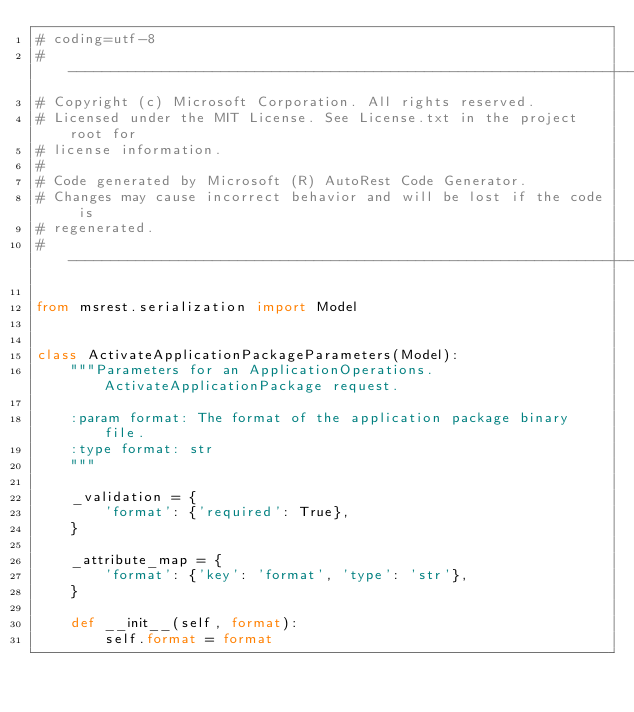<code> <loc_0><loc_0><loc_500><loc_500><_Python_># coding=utf-8
# --------------------------------------------------------------------------
# Copyright (c) Microsoft Corporation. All rights reserved.
# Licensed under the MIT License. See License.txt in the project root for
# license information.
#
# Code generated by Microsoft (R) AutoRest Code Generator.
# Changes may cause incorrect behavior and will be lost if the code is
# regenerated.
# --------------------------------------------------------------------------

from msrest.serialization import Model


class ActivateApplicationPackageParameters(Model):
    """Parameters for an ApplicationOperations.ActivateApplicationPackage request.

    :param format: The format of the application package binary file.
    :type format: str
    """

    _validation = {
        'format': {'required': True},
    }

    _attribute_map = {
        'format': {'key': 'format', 'type': 'str'},
    }

    def __init__(self, format):
        self.format = format
</code> 